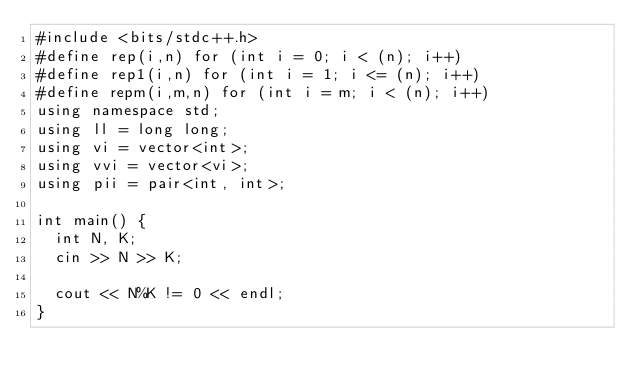Convert code to text. <code><loc_0><loc_0><loc_500><loc_500><_C++_>#include <bits/stdc++.h>
#define rep(i,n) for (int i = 0; i < (n); i++)
#define rep1(i,n) for (int i = 1; i <= (n); i++)
#define repm(i,m,n) for (int i = m; i < (n); i++)
using namespace std;
using ll = long long;
using vi = vector<int>;
using vvi = vector<vi>;
using pii = pair<int, int>;

int main() {
  int N, K;
  cin >> N >> K;
  
  cout << N%K != 0 << endl;
}</code> 